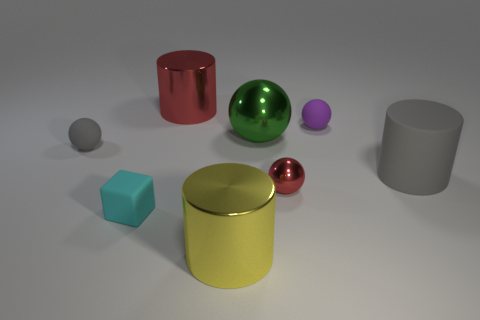There is another shiny object that is the same shape as the big red object; what is its color?
Your response must be concise. Yellow. What number of other objects are the same size as the cyan object?
Ensure brevity in your answer.  3. How big is the rubber cylinder in front of the big red thing?
Offer a very short reply. Large. Are there any other things of the same color as the block?
Your response must be concise. No. Is the material of the red thing in front of the gray rubber cylinder the same as the tiny cube?
Your answer should be very brief. No. How many big objects are behind the yellow cylinder and in front of the small purple matte ball?
Offer a terse response. 2. How big is the shiny cylinder that is in front of the shiny thing that is left of the yellow object?
Provide a short and direct response. Large. Are there more blue cylinders than red balls?
Your answer should be compact. No. Does the cylinder behind the tiny purple sphere have the same color as the metallic thing that is to the right of the large green shiny sphere?
Offer a terse response. Yes. Are there any shiny spheres in front of the big green shiny object to the right of the small gray sphere?
Give a very brief answer. Yes. 